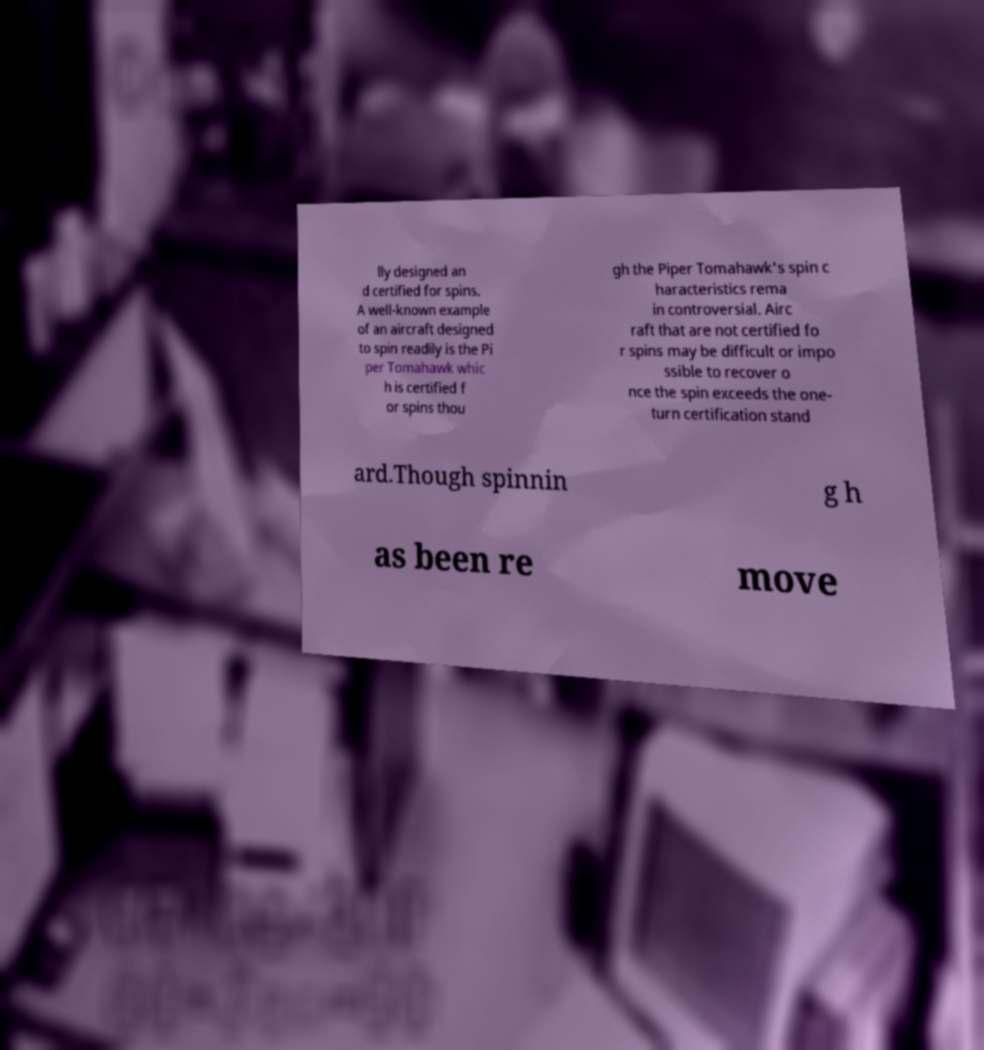For documentation purposes, I need the text within this image transcribed. Could you provide that? lly designed an d certified for spins. A well-known example of an aircraft designed to spin readily is the Pi per Tomahawk whic h is certified f or spins thou gh the Piper Tomahawk's spin c haracteristics rema in controversial. Airc raft that are not certified fo r spins may be difficult or impo ssible to recover o nce the spin exceeds the one- turn certification stand ard.Though spinnin g h as been re move 